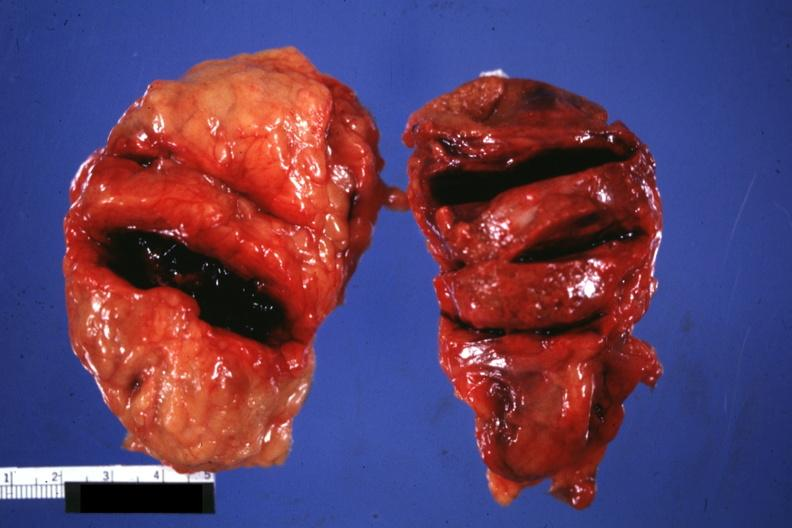s endocrine present?
Answer the question using a single word or phrase. Yes 